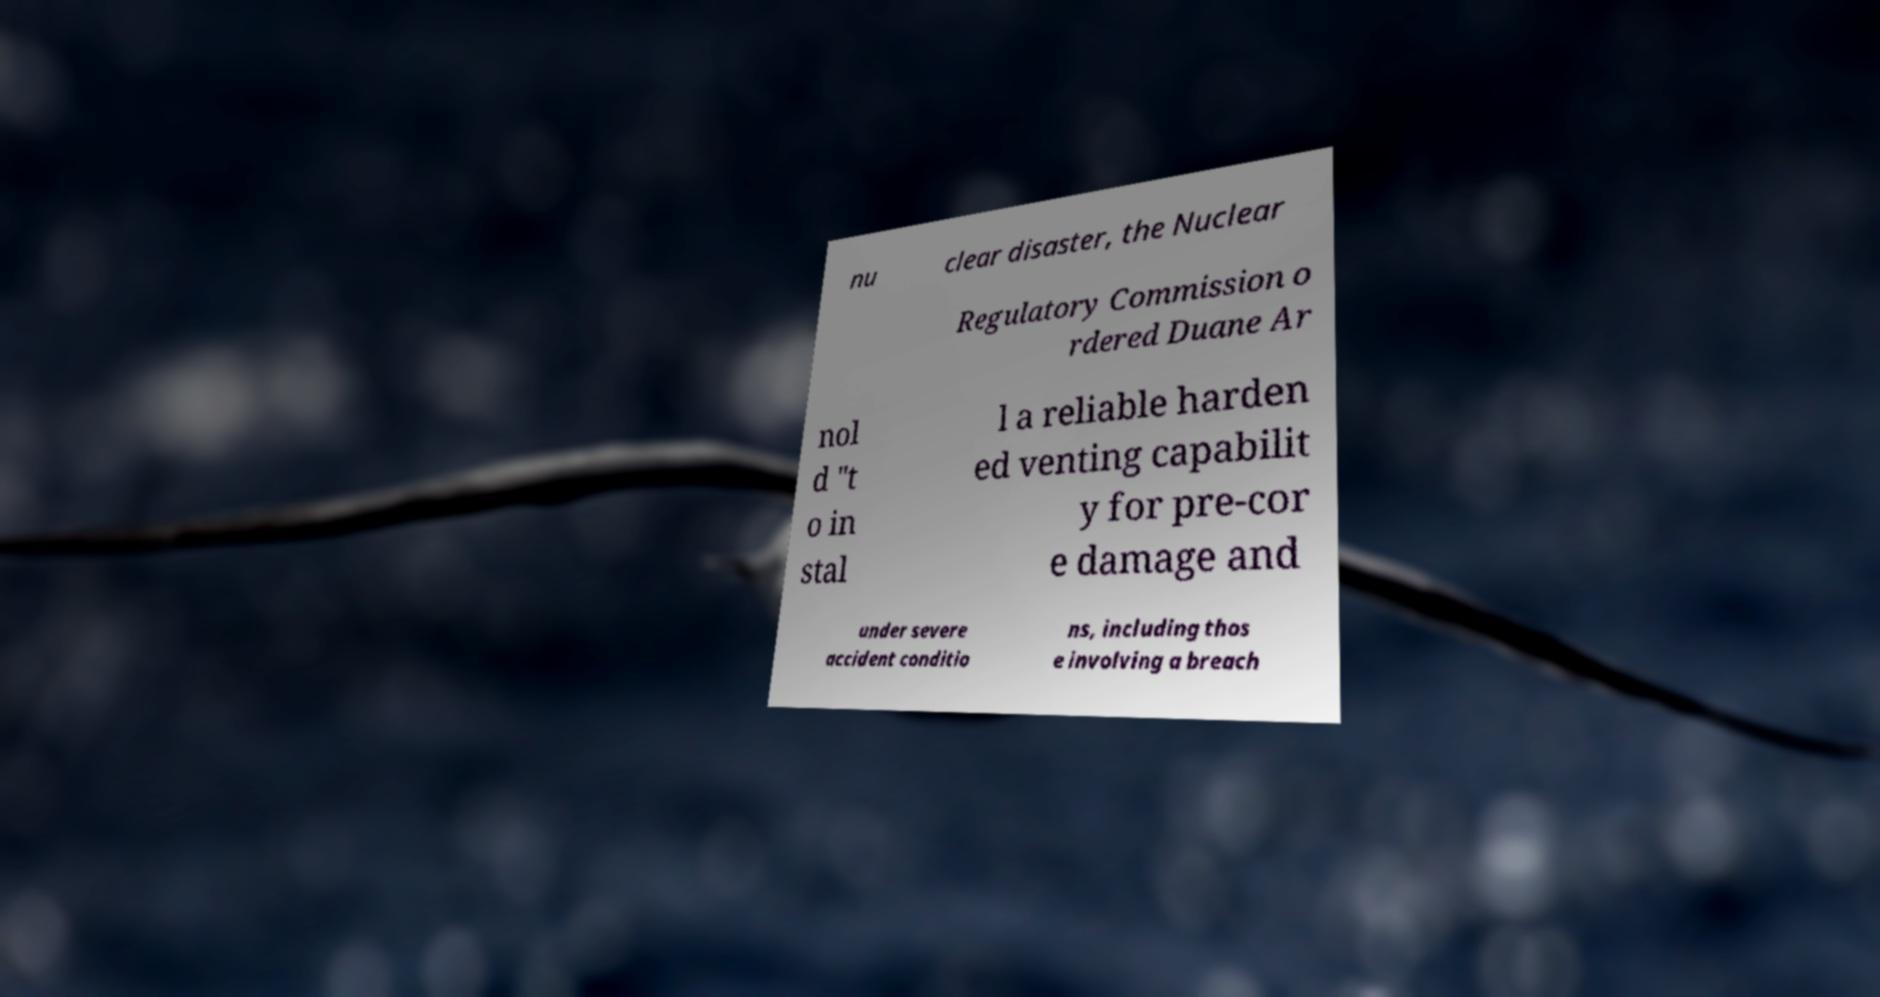For documentation purposes, I need the text within this image transcribed. Could you provide that? nu clear disaster, the Nuclear Regulatory Commission o rdered Duane Ar nol d "t o in stal l a reliable harden ed venting capabilit y for pre-cor e damage and under severe accident conditio ns, including thos e involving a breach 